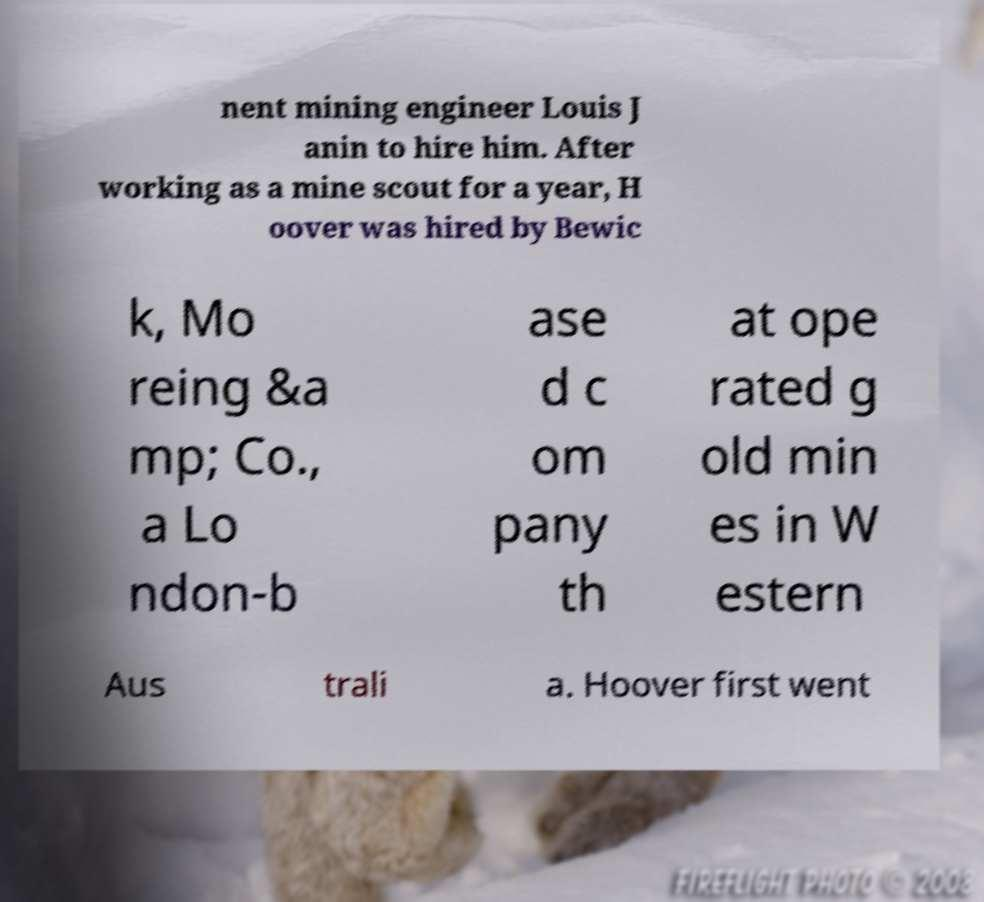There's text embedded in this image that I need extracted. Can you transcribe it verbatim? nent mining engineer Louis J anin to hire him. After working as a mine scout for a year, H oover was hired by Bewic k, Mo reing &a mp; Co., a Lo ndon-b ase d c om pany th at ope rated g old min es in W estern Aus trali a. Hoover first went 